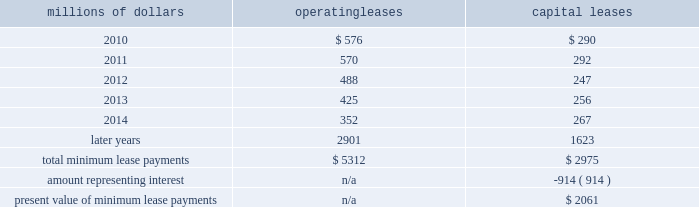14 .
Leases we lease certain locomotives , freight cars , and other property .
The consolidated statement of financial position as of december 31 , 2009 and 2008 included $ 2754 million , net of $ 927 million of accumulated depreciation , and $ 2024 million , net of $ 869 million of accumulated depreciation , respectively , for properties held under capital leases .
A charge to income resulting from the depreciation for assets held under capital leases is included within depreciation expense in our consolidated statements of income .
Future minimum lease payments for operating and capital leases with initial or remaining non-cancelable lease terms in excess of one year as of december 31 , 2009 were as follows : millions of dollars operating leases capital leases .
The majority of capital lease payments relate to locomotives .
Rent expense for operating leases with terms exceeding one month was $ 686 million in 2009 , $ 747 million in 2008 , and $ 810 million in 2007 .
When cash rental payments are not made on a straight-line basis , we recognize variable rental expense on a straight-line basis over the lease term .
Contingent rentals and sub-rentals are not significant .
15 .
Commitments and contingencies asserted and unasserted claims 2013 various claims and lawsuits are pending against us and certain of our subsidiaries .
We cannot fully determine the effect of all asserted and unasserted claims on our consolidated results of operations , financial condition , or liquidity ; however , to the extent possible , where asserted and unasserted claims are considered probable and where such claims can be reasonably estimated , we have recorded a liability .
We do not expect that any known lawsuits , claims , environmental costs , commitments , contingent liabilities , or guarantees will have a material adverse effect on our consolidated results of operations , financial condition , or liquidity after taking into account liabilities and insurance recoveries previously recorded for these matters .
Personal injury 2013 the cost of personal injuries to employees and others related to our activities is charged to expense based on estimates of the ultimate cost and number of incidents each year .
We use third-party actuaries to assist us in measuring the expense and liability , including unasserted claims .
The federal employers 2019 liability act ( fela ) governs compensation for work-related accidents .
Under fela , damages are assessed based on a finding of fault through litigation or out-of-court settlements .
We offer a comprehensive variety of services and rehabilitation programs for employees who are injured at .
What portion of 2009 operating leases are current liabilities? 
Rationale: current is due the following year = 2010
Computations: (576 / 5312)
Answer: 0.10843. 